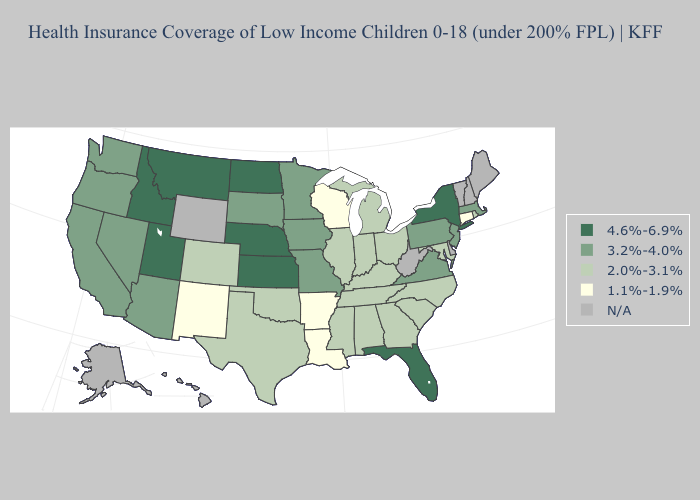What is the value of Connecticut?
Write a very short answer. 1.1%-1.9%. What is the highest value in the Northeast ?
Quick response, please. 4.6%-6.9%. Name the states that have a value in the range 3.2%-4.0%?
Keep it brief. Arizona, California, Iowa, Massachusetts, Minnesota, Missouri, Nevada, New Jersey, Oregon, Pennsylvania, South Dakota, Virginia, Washington. What is the highest value in the USA?
Keep it brief. 4.6%-6.9%. Which states have the lowest value in the MidWest?
Write a very short answer. Wisconsin. What is the value of Connecticut?
Give a very brief answer. 1.1%-1.9%. Is the legend a continuous bar?
Give a very brief answer. No. Among the states that border Oregon , does Idaho have the lowest value?
Be succinct. No. What is the value of North Carolina?
Be succinct. 2.0%-3.1%. Does the first symbol in the legend represent the smallest category?
Quick response, please. No. What is the value of New York?
Answer briefly. 4.6%-6.9%. What is the value of New York?
Short answer required. 4.6%-6.9%. What is the lowest value in the USA?
Be succinct. 1.1%-1.9%. What is the value of California?
Quick response, please. 3.2%-4.0%. 